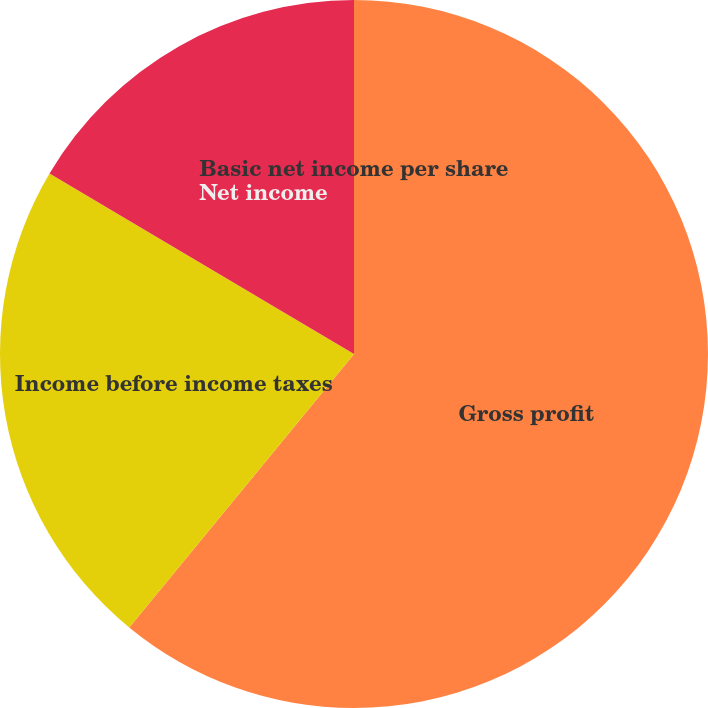Convert chart. <chart><loc_0><loc_0><loc_500><loc_500><pie_chart><fcel>Gross profit<fcel>Income before income taxes<fcel>Net income<fcel>Basic net income per share<nl><fcel>60.95%<fcel>22.57%<fcel>16.48%<fcel>0.0%<nl></chart> 